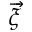<formula> <loc_0><loc_0><loc_500><loc_500>\overrightarrow { \xi }</formula> 